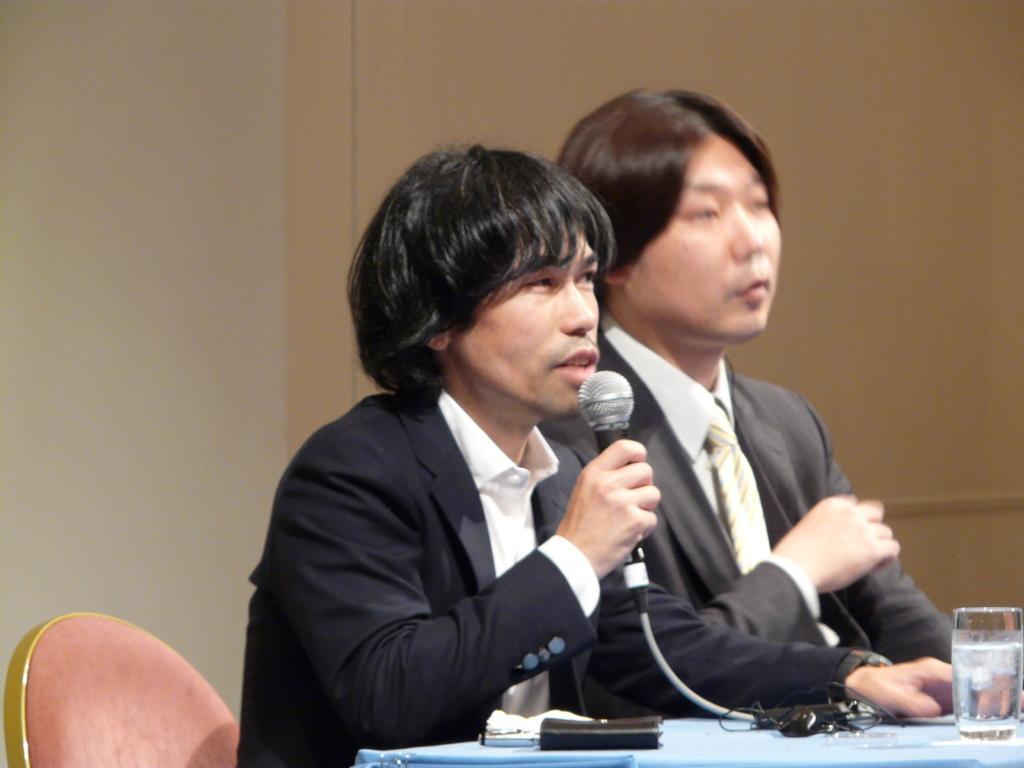How would you summarize this image in a sentence or two? In this picture I can see two people sitting on the chair. I can see the microphone. I can see water glass on the table. 